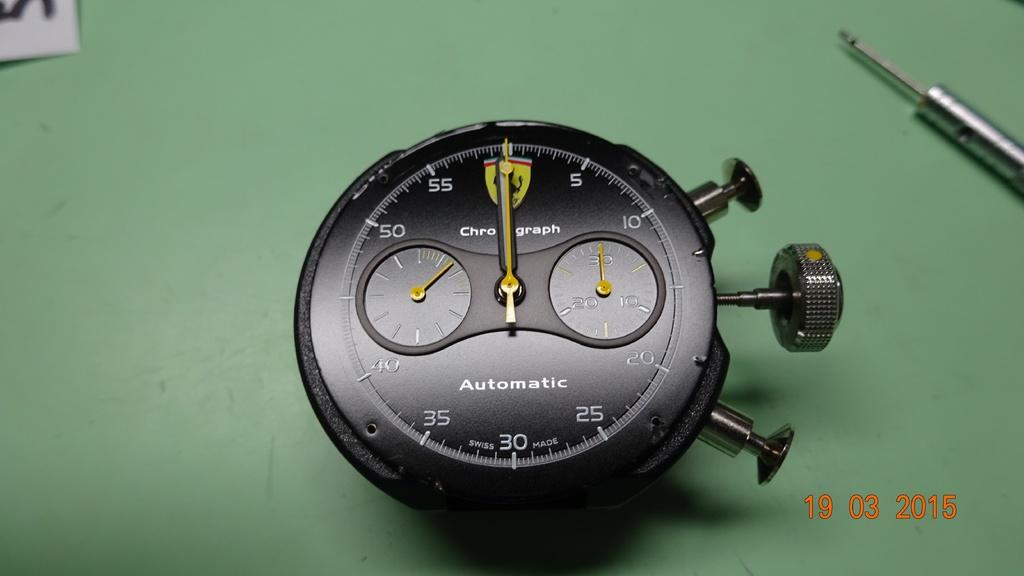<image>
Summarize the visual content of the image. An automatic gauge, removed for closer inspection on a green surface. 